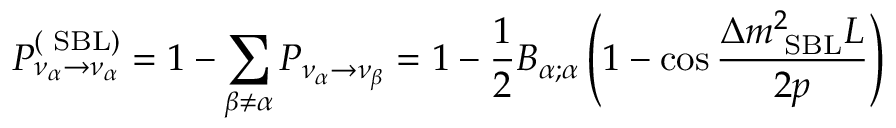Convert formula to latex. <formula><loc_0><loc_0><loc_500><loc_500>P _ { \nu _ { \alpha } \rightarrow \nu _ { \alpha } } ^ { ( S B L ) } = 1 - \sum _ { \beta \neq \alpha } P _ { \nu _ { \alpha } \rightarrow \nu _ { \beta } } = 1 - \frac { 1 } { 2 } B _ { \alpha ; \alpha } \left ( 1 - \cos \frac { \Delta { m } _ { S B L } ^ { 2 } L } { 2 p } \right )</formula> 